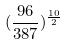<formula> <loc_0><loc_0><loc_500><loc_500>( \frac { 9 6 } { 3 8 7 } ) ^ { \frac { 1 0 } { 2 } }</formula> 